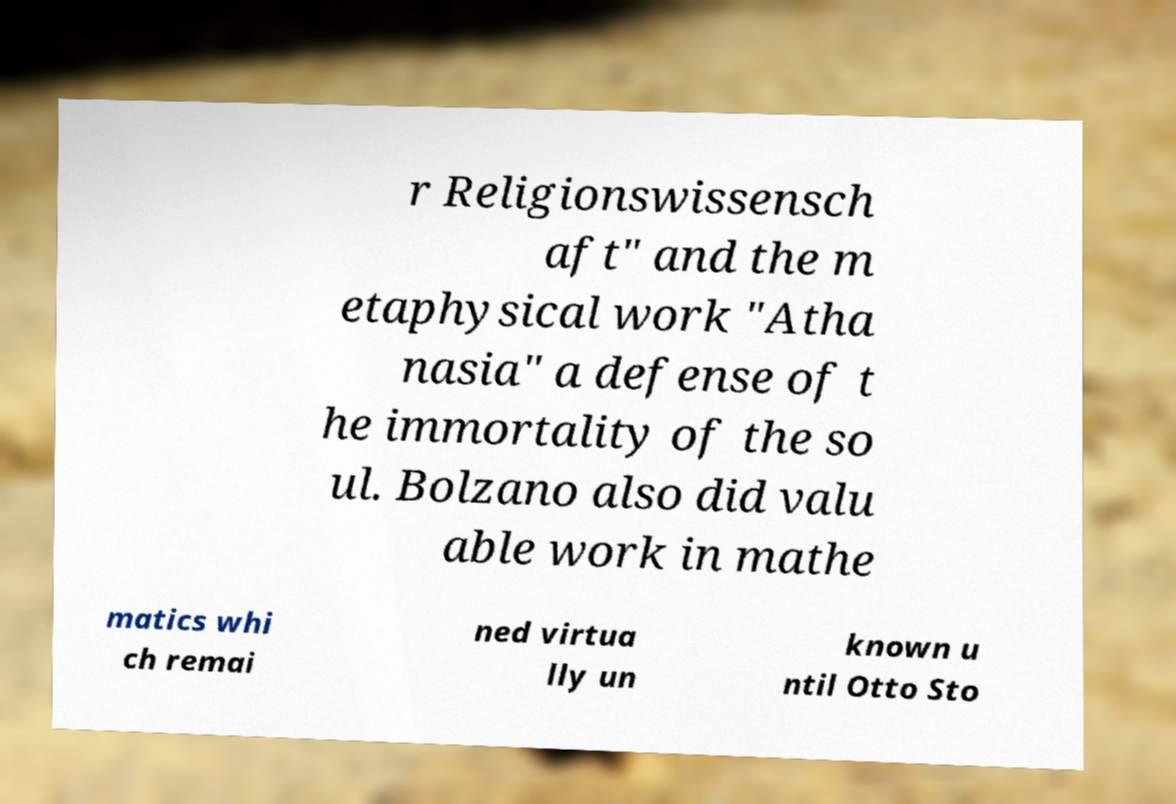Can you accurately transcribe the text from the provided image for me? r Religionswissensch aft" and the m etaphysical work "Atha nasia" a defense of t he immortality of the so ul. Bolzano also did valu able work in mathe matics whi ch remai ned virtua lly un known u ntil Otto Sto 